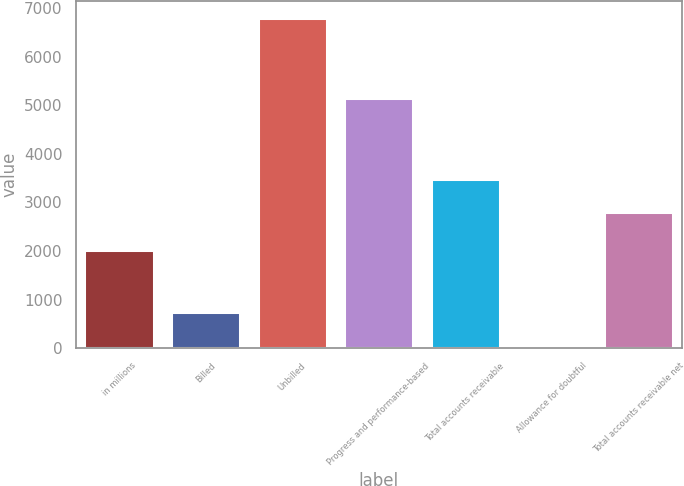Convert chart to OTSL. <chart><loc_0><loc_0><loc_500><loc_500><bar_chart><fcel>in millions<fcel>Billed<fcel>Unbilled<fcel>Progress and performance-based<fcel>Total accounts receivable<fcel>Allowance for doubtful<fcel>Total accounts receivable net<nl><fcel>2014<fcel>741.8<fcel>6806<fcel>5150<fcel>3479.8<fcel>68<fcel>2806<nl></chart> 